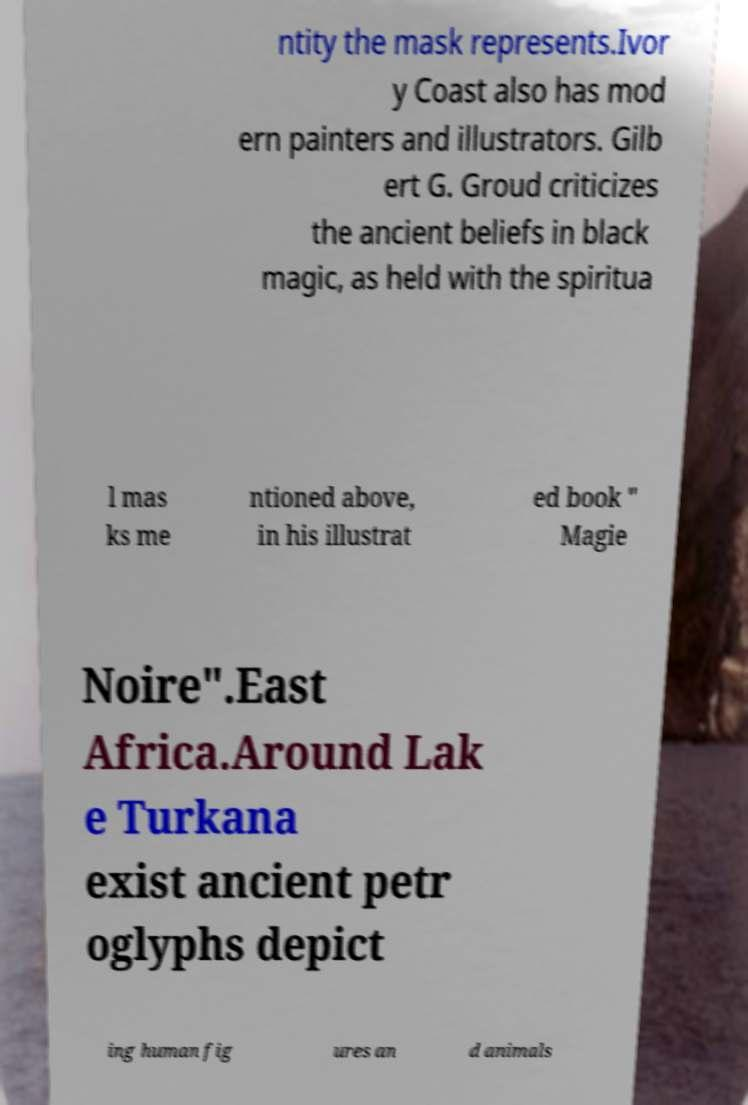Please read and relay the text visible in this image. What does it say? ntity the mask represents.Ivor y Coast also has mod ern painters and illustrators. Gilb ert G. Groud criticizes the ancient beliefs in black magic, as held with the spiritua l mas ks me ntioned above, in his illustrat ed book " Magie Noire".East Africa.Around Lak e Turkana exist ancient petr oglyphs depict ing human fig ures an d animals 